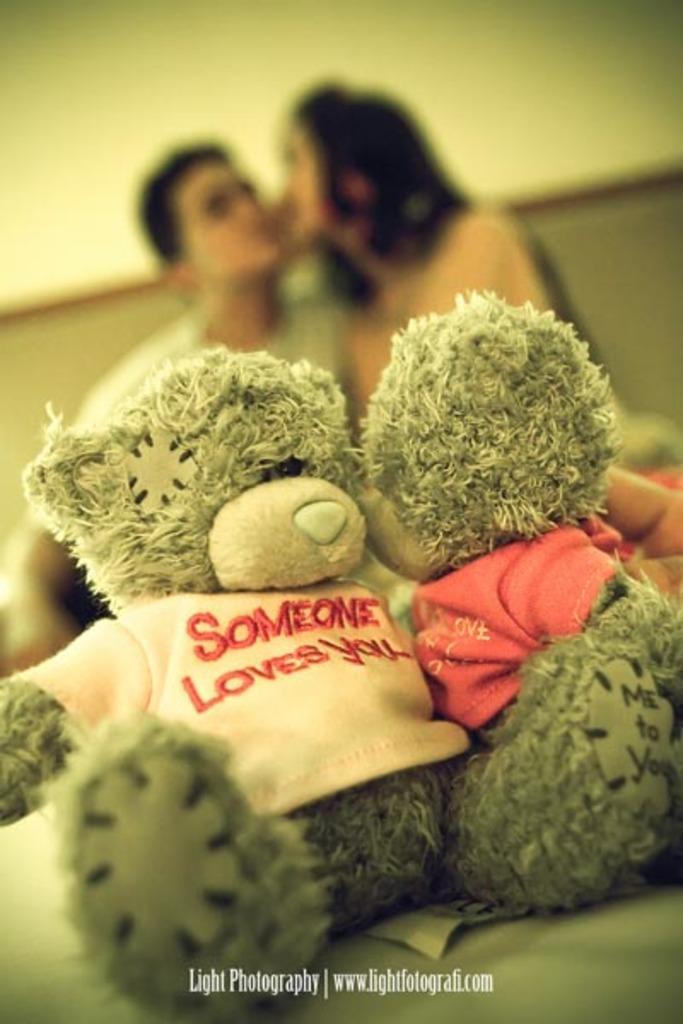Could you give a brief overview of what you see in this image? In this image I can see the toys. In the background I can see two people and the wall. I can see the background is blurred. 